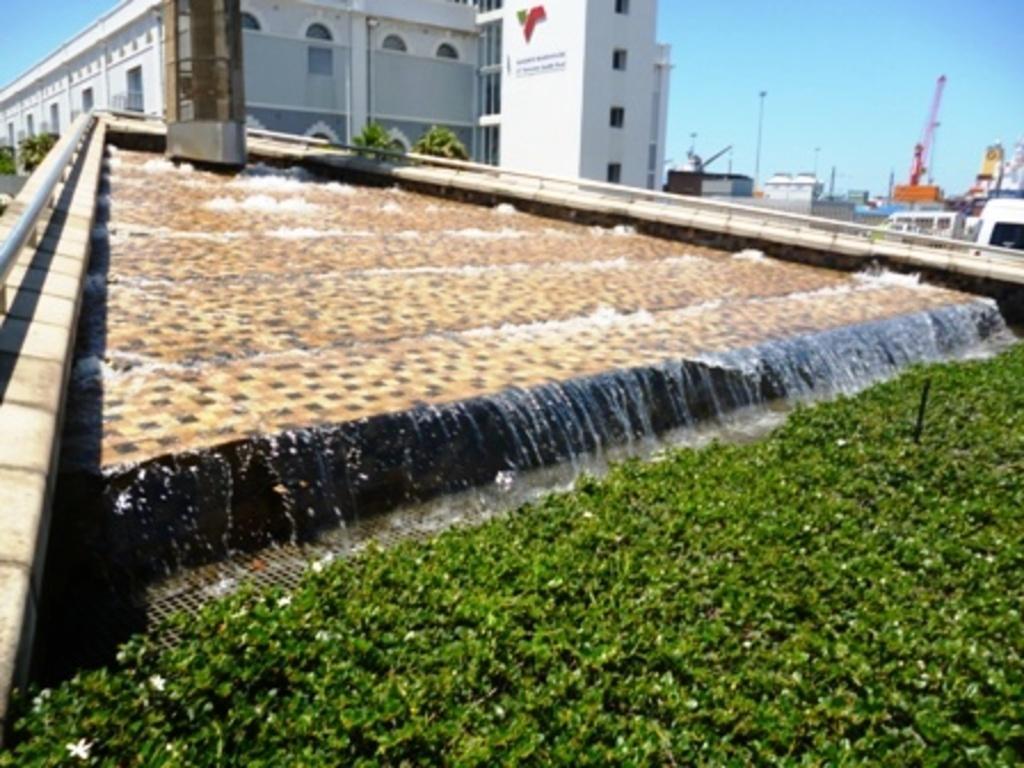In one or two sentences, can you explain what this image depicts? In this image in the front there are plants. In the center there is water which is flowing. In the background there are trees, buildings and there is some text written on the wall of the building, there are vehicles and there are poles. 